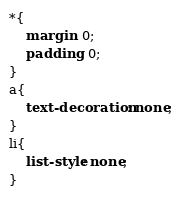<code> <loc_0><loc_0><loc_500><loc_500><_CSS_>*{
    margin: 0;
    padding: 0;
}
a{
    text-decoration: none;
}
li{
    list-style: none;
}</code> 